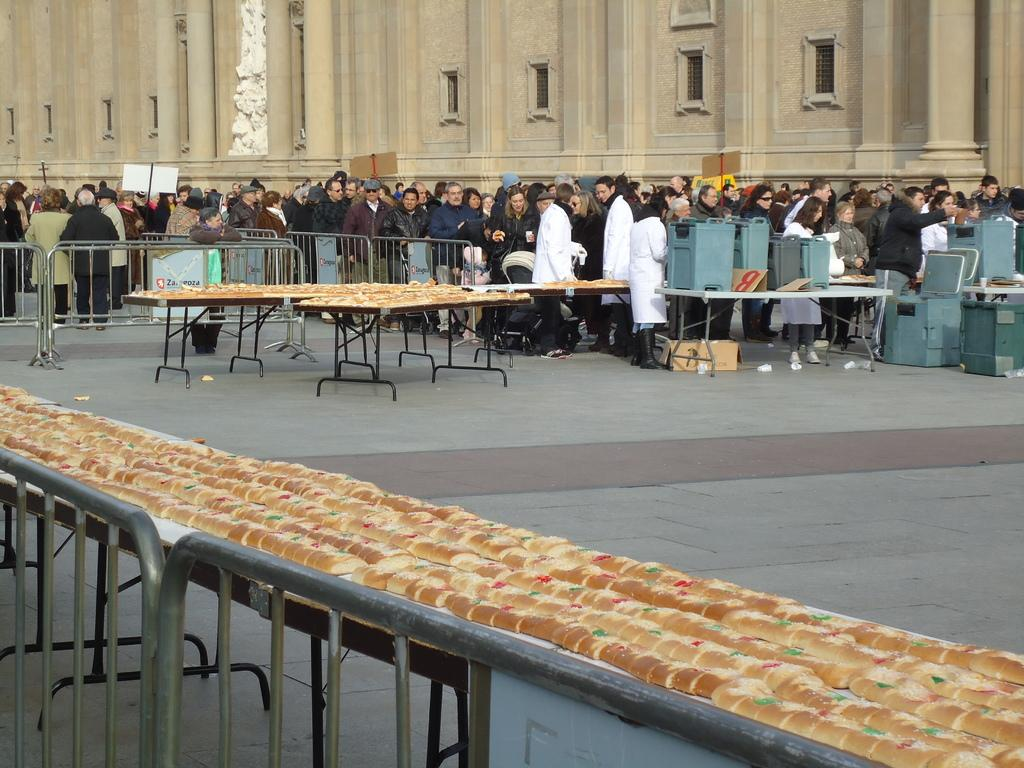What are the people in the image doing? The group of people is standing on the floor. What can be seen in the background of the image? There is a building visible in the image. What is present on the table in the image? There are food items on a table. What type of plants can be seen being operated on in the image? There are no plants or operations present in the image. 